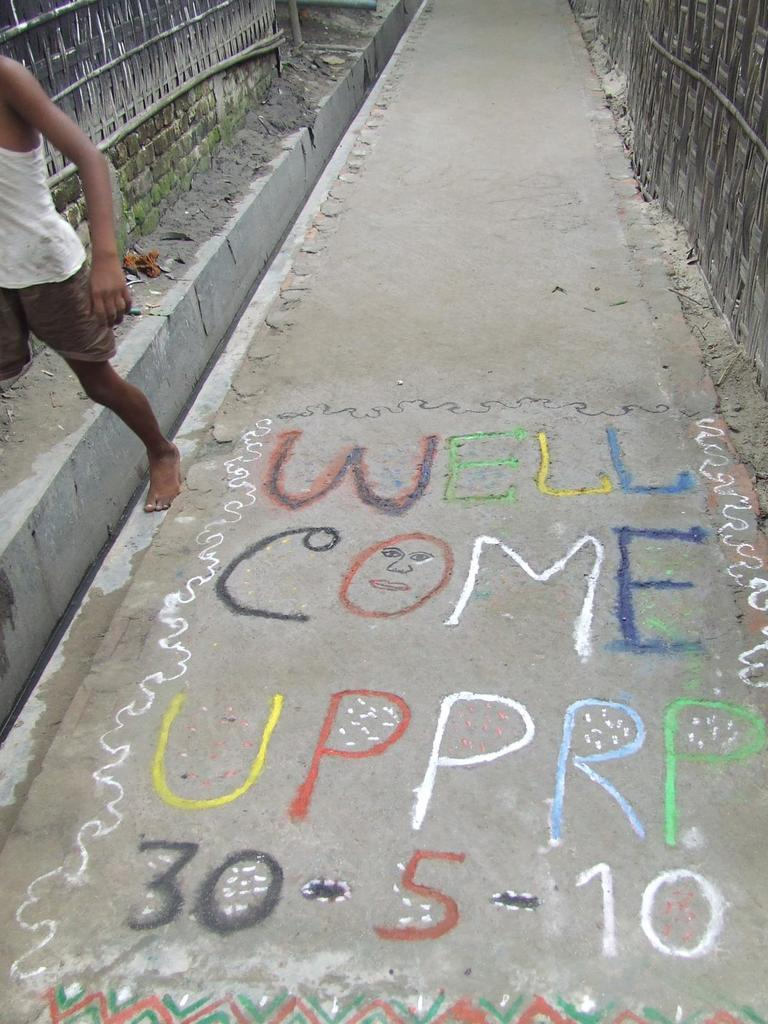What is located on the left side of the image? There is a boy on the left side of the image. What can be seen at the bottom of the image? There is a road at the bottom of the image. What is written on the road? Text is written on the road. What is visible in the background of the image? There is a fence in the background of the image. What type of light can be seen shining on the boy's teeth in the image? There is no light shining on the boy's teeth in the image, nor is there any mention of teeth in the provided facts. What kind of pest is crawling on the fence in the background of the image? There is no pest visible on the fence in the image, nor is there any mention of a pest in the provided facts. 